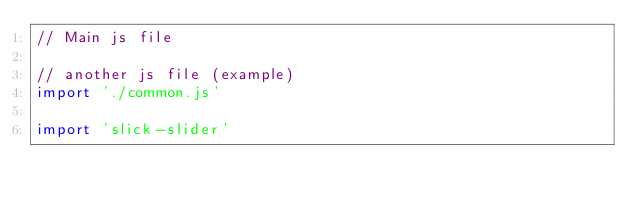Convert code to text. <code><loc_0><loc_0><loc_500><loc_500><_JavaScript_>// Main js file

// another js file (example)
import './common.js'

import 'slick-slider'</code> 